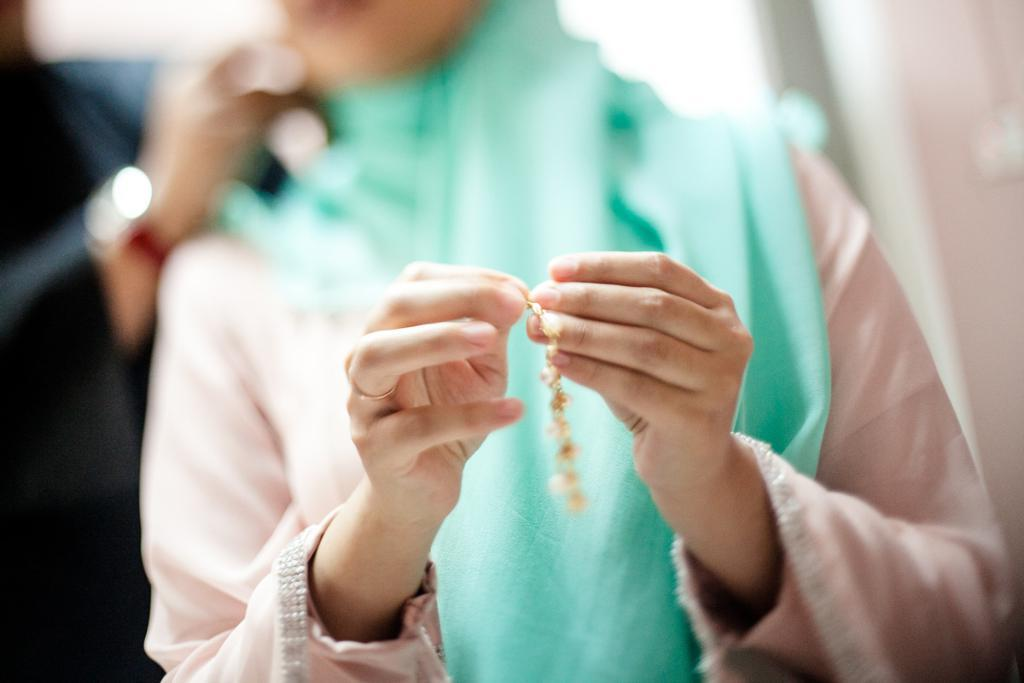What is the person holding in the image? The person is holding jewelry in the image. Can you describe the background of the image? There is a blurry view at the top of the image. Where is the hand of the person located in the image? The hand of the person is visible on the left side of the image. What type of pot is visible on the right side of the image? There is no pot visible on the right side of the image. 